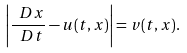Convert formula to latex. <formula><loc_0><loc_0><loc_500><loc_500>\left | \frac { \ D x } { \ D t } - u ( t , x ) \right | = v ( t , x ) .</formula> 